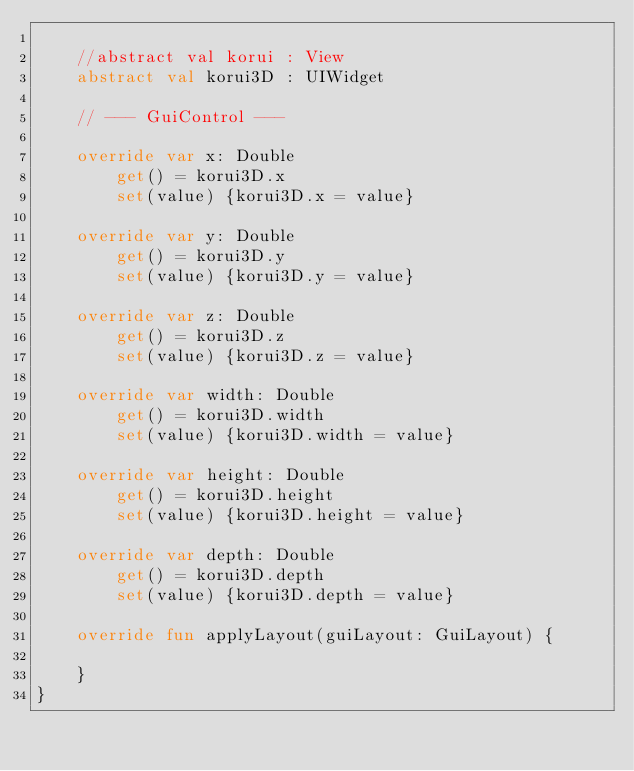Convert code to text. <code><loc_0><loc_0><loc_500><loc_500><_Kotlin_>
    //abstract val korui : View
    abstract val korui3D : UIWidget

    // --- GuiControl ---

    override var x: Double
        get() = korui3D.x
        set(value) {korui3D.x = value}

    override var y: Double
        get() = korui3D.y
        set(value) {korui3D.y = value}

    override var z: Double
        get() = korui3D.z
        set(value) {korui3D.z = value}

    override var width: Double
        get() = korui3D.width
        set(value) {korui3D.width = value}

    override var height: Double
        get() = korui3D.height
        set(value) {korui3D.height = value}

    override var depth: Double
        get() = korui3D.depth
        set(value) {korui3D.depth = value}

    override fun applyLayout(guiLayout: GuiLayout) {

    }
}</code> 